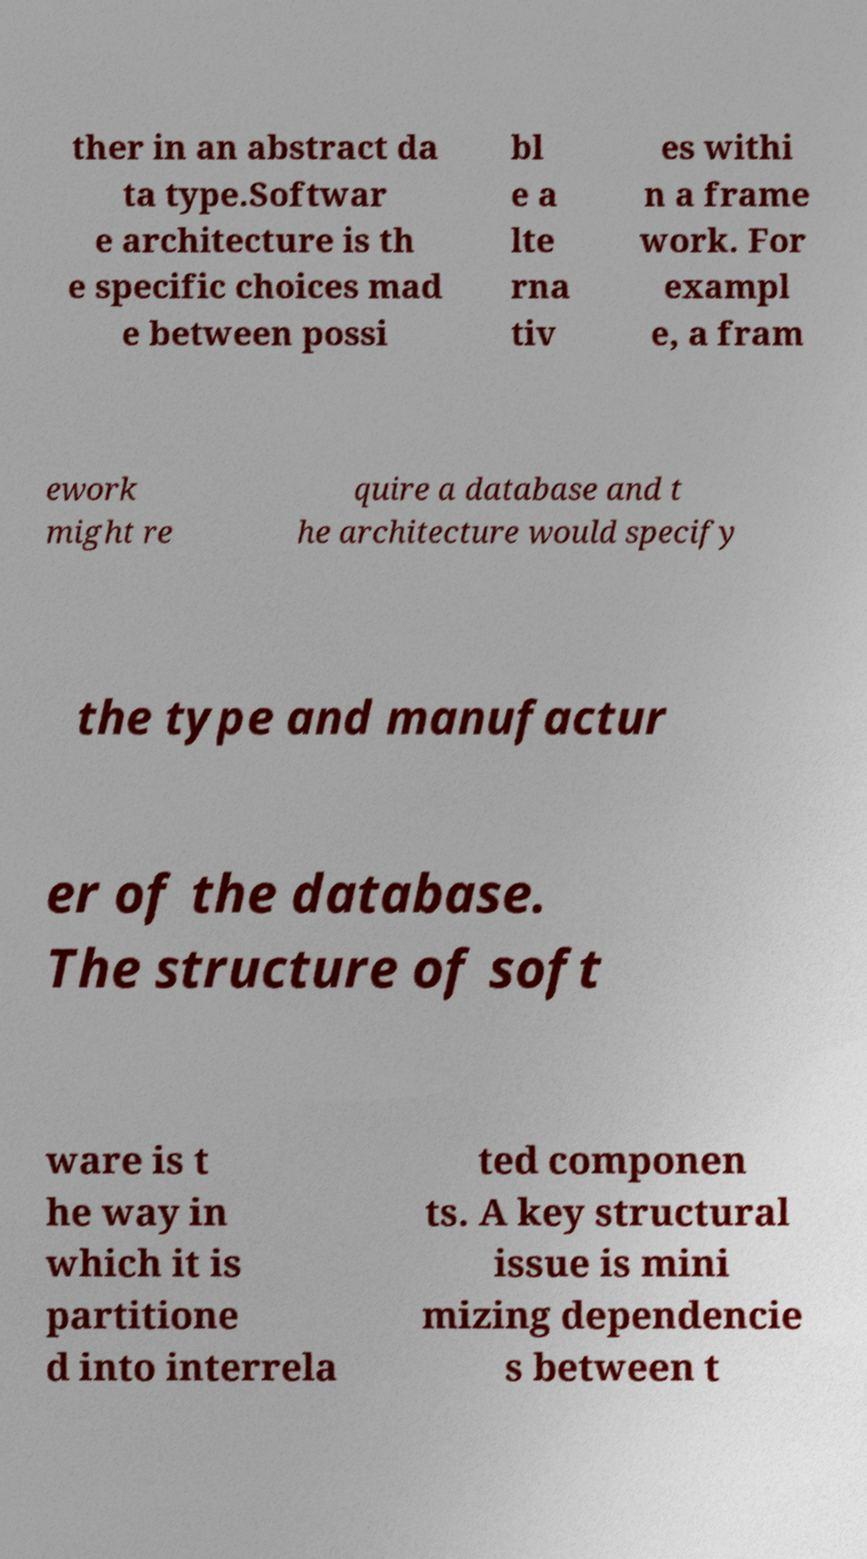Please read and relay the text visible in this image. What does it say? ther in an abstract da ta type.Softwar e architecture is th e specific choices mad e between possi bl e a lte rna tiv es withi n a frame work. For exampl e, a fram ework might re quire a database and t he architecture would specify the type and manufactur er of the database. The structure of soft ware is t he way in which it is partitione d into interrela ted componen ts. A key structural issue is mini mizing dependencie s between t 